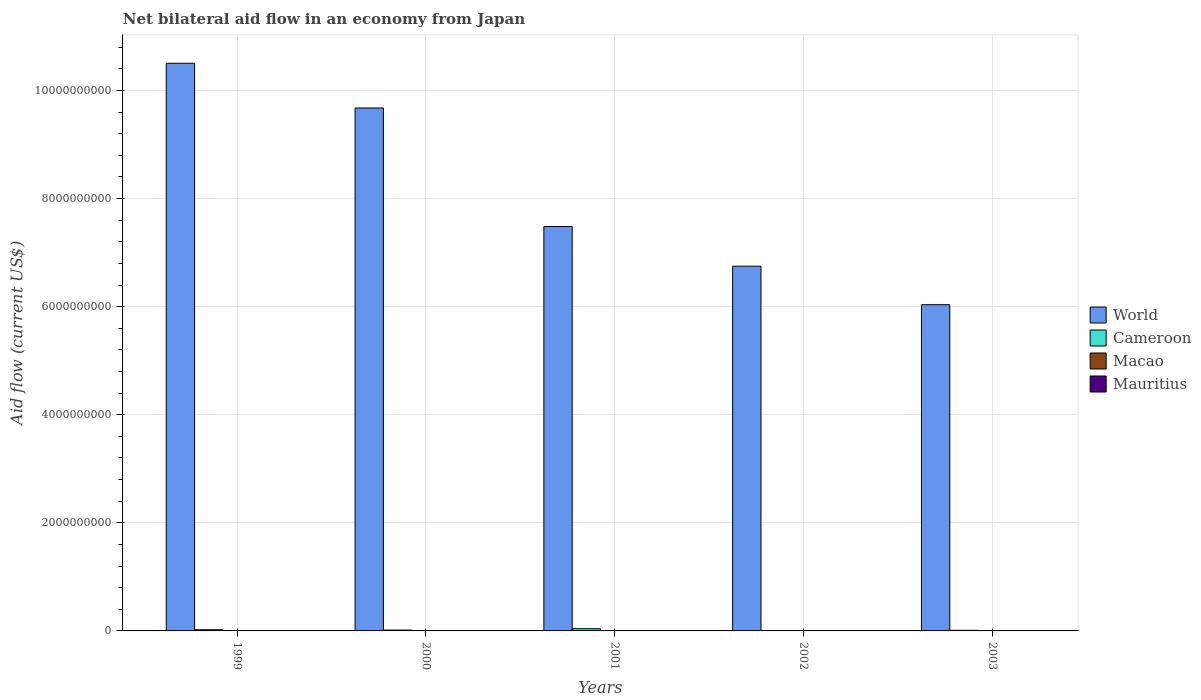How many different coloured bars are there?
Keep it short and to the point. 4. How many bars are there on the 2nd tick from the right?
Provide a succinct answer. 4. What is the net bilateral aid flow in World in 2003?
Provide a succinct answer. 6.04e+09. Across all years, what is the maximum net bilateral aid flow in Mauritius?
Offer a very short reply. 2.92e+06. Across all years, what is the minimum net bilateral aid flow in Mauritius?
Make the answer very short. 6.90e+05. In which year was the net bilateral aid flow in Mauritius maximum?
Keep it short and to the point. 2003. What is the total net bilateral aid flow in Cameroon in the graph?
Offer a terse response. 9.73e+07. What is the difference between the net bilateral aid flow in World in 2000 and that in 2003?
Offer a very short reply. 3.64e+09. What is the difference between the net bilateral aid flow in Mauritius in 2003 and the net bilateral aid flow in Cameroon in 2002?
Offer a terse response. -4.59e+06. What is the average net bilateral aid flow in Mauritius per year?
Provide a short and direct response. 1.95e+06. In the year 2000, what is the difference between the net bilateral aid flow in Macao and net bilateral aid flow in Mauritius?
Your answer should be compact. -1.98e+06. In how many years, is the net bilateral aid flow in World greater than 4000000000 US$?
Ensure brevity in your answer.  5. What is the ratio of the net bilateral aid flow in Macao in 1999 to that in 2000?
Offer a very short reply. 1.4. Is the net bilateral aid flow in Mauritius in 1999 less than that in 2003?
Offer a very short reply. Yes. Is the difference between the net bilateral aid flow in Macao in 2000 and 2002 greater than the difference between the net bilateral aid flow in Mauritius in 2000 and 2002?
Provide a short and direct response. No. What is the difference between the highest and the second highest net bilateral aid flow in World?
Make the answer very short. 8.27e+08. What is the difference between the highest and the lowest net bilateral aid flow in Mauritius?
Provide a short and direct response. 2.23e+06. Is the sum of the net bilateral aid flow in World in 1999 and 2000 greater than the maximum net bilateral aid flow in Macao across all years?
Make the answer very short. Yes. Is it the case that in every year, the sum of the net bilateral aid flow in Mauritius and net bilateral aid flow in Cameroon is greater than the sum of net bilateral aid flow in Macao and net bilateral aid flow in World?
Provide a succinct answer. Yes. What does the 4th bar from the left in 2001 represents?
Provide a short and direct response. Mauritius. How many bars are there?
Ensure brevity in your answer.  20. Are all the bars in the graph horizontal?
Ensure brevity in your answer.  No. How many years are there in the graph?
Offer a terse response. 5. Does the graph contain grids?
Your answer should be compact. Yes. What is the title of the graph?
Provide a short and direct response. Net bilateral aid flow in an economy from Japan. Does "Belgium" appear as one of the legend labels in the graph?
Ensure brevity in your answer.  No. What is the label or title of the X-axis?
Your answer should be compact. Years. What is the Aid flow (current US$) in World in 1999?
Ensure brevity in your answer.  1.05e+1. What is the Aid flow (current US$) of Cameroon in 1999?
Offer a terse response. 2.19e+07. What is the Aid flow (current US$) of Mauritius in 1999?
Offer a very short reply. 2.72e+06. What is the Aid flow (current US$) of World in 2000?
Offer a very short reply. 9.68e+09. What is the Aid flow (current US$) of Cameroon in 2000?
Your answer should be compact. 1.58e+07. What is the Aid flow (current US$) of Macao in 2000?
Keep it short and to the point. 1.50e+05. What is the Aid flow (current US$) in Mauritius in 2000?
Keep it short and to the point. 2.13e+06. What is the Aid flow (current US$) in World in 2001?
Offer a terse response. 7.48e+09. What is the Aid flow (current US$) in Cameroon in 2001?
Give a very brief answer. 4.13e+07. What is the Aid flow (current US$) of Mauritius in 2001?
Your answer should be very brief. 1.30e+06. What is the Aid flow (current US$) of World in 2002?
Provide a succinct answer. 6.75e+09. What is the Aid flow (current US$) in Cameroon in 2002?
Offer a terse response. 7.51e+06. What is the Aid flow (current US$) of Macao in 2002?
Keep it short and to the point. 1.00e+05. What is the Aid flow (current US$) of Mauritius in 2002?
Your response must be concise. 6.90e+05. What is the Aid flow (current US$) of World in 2003?
Give a very brief answer. 6.04e+09. What is the Aid flow (current US$) of Cameroon in 2003?
Your response must be concise. 1.08e+07. What is the Aid flow (current US$) in Macao in 2003?
Offer a very short reply. 8.00e+04. What is the Aid flow (current US$) in Mauritius in 2003?
Make the answer very short. 2.92e+06. Across all years, what is the maximum Aid flow (current US$) of World?
Ensure brevity in your answer.  1.05e+1. Across all years, what is the maximum Aid flow (current US$) of Cameroon?
Keep it short and to the point. 4.13e+07. Across all years, what is the maximum Aid flow (current US$) in Macao?
Keep it short and to the point. 2.10e+05. Across all years, what is the maximum Aid flow (current US$) of Mauritius?
Your answer should be very brief. 2.92e+06. Across all years, what is the minimum Aid flow (current US$) in World?
Offer a terse response. 6.04e+09. Across all years, what is the minimum Aid flow (current US$) in Cameroon?
Keep it short and to the point. 7.51e+06. Across all years, what is the minimum Aid flow (current US$) in Macao?
Provide a succinct answer. 8.00e+04. Across all years, what is the minimum Aid flow (current US$) of Mauritius?
Give a very brief answer. 6.90e+05. What is the total Aid flow (current US$) in World in the graph?
Your answer should be compact. 4.04e+1. What is the total Aid flow (current US$) of Cameroon in the graph?
Provide a succinct answer. 9.73e+07. What is the total Aid flow (current US$) in Macao in the graph?
Your answer should be very brief. 6.70e+05. What is the total Aid flow (current US$) of Mauritius in the graph?
Offer a very short reply. 9.76e+06. What is the difference between the Aid flow (current US$) of World in 1999 and that in 2000?
Ensure brevity in your answer.  8.27e+08. What is the difference between the Aid flow (current US$) of Cameroon in 1999 and that in 2000?
Provide a short and direct response. 6.09e+06. What is the difference between the Aid flow (current US$) of Macao in 1999 and that in 2000?
Offer a very short reply. 6.00e+04. What is the difference between the Aid flow (current US$) of Mauritius in 1999 and that in 2000?
Provide a short and direct response. 5.90e+05. What is the difference between the Aid flow (current US$) in World in 1999 and that in 2001?
Keep it short and to the point. 3.02e+09. What is the difference between the Aid flow (current US$) of Cameroon in 1999 and that in 2001?
Offer a very short reply. -1.94e+07. What is the difference between the Aid flow (current US$) in Mauritius in 1999 and that in 2001?
Make the answer very short. 1.42e+06. What is the difference between the Aid flow (current US$) of World in 1999 and that in 2002?
Your response must be concise. 3.75e+09. What is the difference between the Aid flow (current US$) of Cameroon in 1999 and that in 2002?
Your response must be concise. 1.44e+07. What is the difference between the Aid flow (current US$) of Macao in 1999 and that in 2002?
Keep it short and to the point. 1.10e+05. What is the difference between the Aid flow (current US$) in Mauritius in 1999 and that in 2002?
Keep it short and to the point. 2.03e+06. What is the difference between the Aid flow (current US$) of World in 1999 and that in 2003?
Ensure brevity in your answer.  4.47e+09. What is the difference between the Aid flow (current US$) of Cameroon in 1999 and that in 2003?
Keep it short and to the point. 1.11e+07. What is the difference between the Aid flow (current US$) of Macao in 1999 and that in 2003?
Provide a succinct answer. 1.30e+05. What is the difference between the Aid flow (current US$) of World in 2000 and that in 2001?
Give a very brief answer. 2.19e+09. What is the difference between the Aid flow (current US$) in Cameroon in 2000 and that in 2001?
Keep it short and to the point. -2.55e+07. What is the difference between the Aid flow (current US$) of Macao in 2000 and that in 2001?
Provide a short and direct response. 2.00e+04. What is the difference between the Aid flow (current US$) in Mauritius in 2000 and that in 2001?
Your response must be concise. 8.30e+05. What is the difference between the Aid flow (current US$) of World in 2000 and that in 2002?
Your response must be concise. 2.93e+09. What is the difference between the Aid flow (current US$) of Cameroon in 2000 and that in 2002?
Ensure brevity in your answer.  8.30e+06. What is the difference between the Aid flow (current US$) in Macao in 2000 and that in 2002?
Your response must be concise. 5.00e+04. What is the difference between the Aid flow (current US$) of Mauritius in 2000 and that in 2002?
Offer a terse response. 1.44e+06. What is the difference between the Aid flow (current US$) of World in 2000 and that in 2003?
Keep it short and to the point. 3.64e+09. What is the difference between the Aid flow (current US$) in Cameroon in 2000 and that in 2003?
Ensure brevity in your answer.  5.02e+06. What is the difference between the Aid flow (current US$) of Mauritius in 2000 and that in 2003?
Ensure brevity in your answer.  -7.90e+05. What is the difference between the Aid flow (current US$) in World in 2001 and that in 2002?
Offer a very short reply. 7.34e+08. What is the difference between the Aid flow (current US$) of Cameroon in 2001 and that in 2002?
Provide a succinct answer. 3.38e+07. What is the difference between the Aid flow (current US$) of Macao in 2001 and that in 2002?
Offer a very short reply. 3.00e+04. What is the difference between the Aid flow (current US$) in Mauritius in 2001 and that in 2002?
Keep it short and to the point. 6.10e+05. What is the difference between the Aid flow (current US$) of World in 2001 and that in 2003?
Your response must be concise. 1.45e+09. What is the difference between the Aid flow (current US$) in Cameroon in 2001 and that in 2003?
Provide a succinct answer. 3.05e+07. What is the difference between the Aid flow (current US$) of Macao in 2001 and that in 2003?
Offer a terse response. 5.00e+04. What is the difference between the Aid flow (current US$) in Mauritius in 2001 and that in 2003?
Your answer should be compact. -1.62e+06. What is the difference between the Aid flow (current US$) in World in 2002 and that in 2003?
Keep it short and to the point. 7.12e+08. What is the difference between the Aid flow (current US$) in Cameroon in 2002 and that in 2003?
Offer a terse response. -3.28e+06. What is the difference between the Aid flow (current US$) of Macao in 2002 and that in 2003?
Keep it short and to the point. 2.00e+04. What is the difference between the Aid flow (current US$) of Mauritius in 2002 and that in 2003?
Your answer should be compact. -2.23e+06. What is the difference between the Aid flow (current US$) of World in 1999 and the Aid flow (current US$) of Cameroon in 2000?
Offer a terse response. 1.05e+1. What is the difference between the Aid flow (current US$) in World in 1999 and the Aid flow (current US$) in Macao in 2000?
Give a very brief answer. 1.05e+1. What is the difference between the Aid flow (current US$) of World in 1999 and the Aid flow (current US$) of Mauritius in 2000?
Offer a very short reply. 1.05e+1. What is the difference between the Aid flow (current US$) in Cameroon in 1999 and the Aid flow (current US$) in Macao in 2000?
Offer a very short reply. 2.18e+07. What is the difference between the Aid flow (current US$) of Cameroon in 1999 and the Aid flow (current US$) of Mauritius in 2000?
Keep it short and to the point. 1.98e+07. What is the difference between the Aid flow (current US$) of Macao in 1999 and the Aid flow (current US$) of Mauritius in 2000?
Your response must be concise. -1.92e+06. What is the difference between the Aid flow (current US$) of World in 1999 and the Aid flow (current US$) of Cameroon in 2001?
Make the answer very short. 1.05e+1. What is the difference between the Aid flow (current US$) of World in 1999 and the Aid flow (current US$) of Macao in 2001?
Your answer should be compact. 1.05e+1. What is the difference between the Aid flow (current US$) of World in 1999 and the Aid flow (current US$) of Mauritius in 2001?
Provide a short and direct response. 1.05e+1. What is the difference between the Aid flow (current US$) in Cameroon in 1999 and the Aid flow (current US$) in Macao in 2001?
Your answer should be very brief. 2.18e+07. What is the difference between the Aid flow (current US$) in Cameroon in 1999 and the Aid flow (current US$) in Mauritius in 2001?
Your response must be concise. 2.06e+07. What is the difference between the Aid flow (current US$) in Macao in 1999 and the Aid flow (current US$) in Mauritius in 2001?
Provide a succinct answer. -1.09e+06. What is the difference between the Aid flow (current US$) of World in 1999 and the Aid flow (current US$) of Cameroon in 2002?
Your response must be concise. 1.05e+1. What is the difference between the Aid flow (current US$) in World in 1999 and the Aid flow (current US$) in Macao in 2002?
Your answer should be very brief. 1.05e+1. What is the difference between the Aid flow (current US$) of World in 1999 and the Aid flow (current US$) of Mauritius in 2002?
Provide a short and direct response. 1.05e+1. What is the difference between the Aid flow (current US$) in Cameroon in 1999 and the Aid flow (current US$) in Macao in 2002?
Offer a very short reply. 2.18e+07. What is the difference between the Aid flow (current US$) in Cameroon in 1999 and the Aid flow (current US$) in Mauritius in 2002?
Offer a very short reply. 2.12e+07. What is the difference between the Aid flow (current US$) of Macao in 1999 and the Aid flow (current US$) of Mauritius in 2002?
Offer a terse response. -4.80e+05. What is the difference between the Aid flow (current US$) of World in 1999 and the Aid flow (current US$) of Cameroon in 2003?
Make the answer very short. 1.05e+1. What is the difference between the Aid flow (current US$) of World in 1999 and the Aid flow (current US$) of Macao in 2003?
Provide a short and direct response. 1.05e+1. What is the difference between the Aid flow (current US$) of World in 1999 and the Aid flow (current US$) of Mauritius in 2003?
Your answer should be very brief. 1.05e+1. What is the difference between the Aid flow (current US$) of Cameroon in 1999 and the Aid flow (current US$) of Macao in 2003?
Your answer should be compact. 2.18e+07. What is the difference between the Aid flow (current US$) of Cameroon in 1999 and the Aid flow (current US$) of Mauritius in 2003?
Provide a short and direct response. 1.90e+07. What is the difference between the Aid flow (current US$) of Macao in 1999 and the Aid flow (current US$) of Mauritius in 2003?
Provide a succinct answer. -2.71e+06. What is the difference between the Aid flow (current US$) of World in 2000 and the Aid flow (current US$) of Cameroon in 2001?
Offer a terse response. 9.63e+09. What is the difference between the Aid flow (current US$) in World in 2000 and the Aid flow (current US$) in Macao in 2001?
Offer a terse response. 9.68e+09. What is the difference between the Aid flow (current US$) of World in 2000 and the Aid flow (current US$) of Mauritius in 2001?
Offer a very short reply. 9.67e+09. What is the difference between the Aid flow (current US$) of Cameroon in 2000 and the Aid flow (current US$) of Macao in 2001?
Provide a succinct answer. 1.57e+07. What is the difference between the Aid flow (current US$) of Cameroon in 2000 and the Aid flow (current US$) of Mauritius in 2001?
Provide a short and direct response. 1.45e+07. What is the difference between the Aid flow (current US$) of Macao in 2000 and the Aid flow (current US$) of Mauritius in 2001?
Offer a very short reply. -1.15e+06. What is the difference between the Aid flow (current US$) in World in 2000 and the Aid flow (current US$) in Cameroon in 2002?
Your response must be concise. 9.67e+09. What is the difference between the Aid flow (current US$) in World in 2000 and the Aid flow (current US$) in Macao in 2002?
Provide a succinct answer. 9.68e+09. What is the difference between the Aid flow (current US$) of World in 2000 and the Aid flow (current US$) of Mauritius in 2002?
Offer a very short reply. 9.67e+09. What is the difference between the Aid flow (current US$) of Cameroon in 2000 and the Aid flow (current US$) of Macao in 2002?
Your answer should be very brief. 1.57e+07. What is the difference between the Aid flow (current US$) of Cameroon in 2000 and the Aid flow (current US$) of Mauritius in 2002?
Your answer should be very brief. 1.51e+07. What is the difference between the Aid flow (current US$) in Macao in 2000 and the Aid flow (current US$) in Mauritius in 2002?
Offer a very short reply. -5.40e+05. What is the difference between the Aid flow (current US$) of World in 2000 and the Aid flow (current US$) of Cameroon in 2003?
Make the answer very short. 9.66e+09. What is the difference between the Aid flow (current US$) of World in 2000 and the Aid flow (current US$) of Macao in 2003?
Offer a terse response. 9.68e+09. What is the difference between the Aid flow (current US$) in World in 2000 and the Aid flow (current US$) in Mauritius in 2003?
Give a very brief answer. 9.67e+09. What is the difference between the Aid flow (current US$) of Cameroon in 2000 and the Aid flow (current US$) of Macao in 2003?
Give a very brief answer. 1.57e+07. What is the difference between the Aid flow (current US$) in Cameroon in 2000 and the Aid flow (current US$) in Mauritius in 2003?
Your answer should be very brief. 1.29e+07. What is the difference between the Aid flow (current US$) of Macao in 2000 and the Aid flow (current US$) of Mauritius in 2003?
Your answer should be compact. -2.77e+06. What is the difference between the Aid flow (current US$) of World in 2001 and the Aid flow (current US$) of Cameroon in 2002?
Your response must be concise. 7.47e+09. What is the difference between the Aid flow (current US$) of World in 2001 and the Aid flow (current US$) of Macao in 2002?
Your response must be concise. 7.48e+09. What is the difference between the Aid flow (current US$) in World in 2001 and the Aid flow (current US$) in Mauritius in 2002?
Offer a very short reply. 7.48e+09. What is the difference between the Aid flow (current US$) of Cameroon in 2001 and the Aid flow (current US$) of Macao in 2002?
Your answer should be very brief. 4.12e+07. What is the difference between the Aid flow (current US$) of Cameroon in 2001 and the Aid flow (current US$) of Mauritius in 2002?
Give a very brief answer. 4.06e+07. What is the difference between the Aid flow (current US$) in Macao in 2001 and the Aid flow (current US$) in Mauritius in 2002?
Make the answer very short. -5.60e+05. What is the difference between the Aid flow (current US$) in World in 2001 and the Aid flow (current US$) in Cameroon in 2003?
Make the answer very short. 7.47e+09. What is the difference between the Aid flow (current US$) in World in 2001 and the Aid flow (current US$) in Macao in 2003?
Offer a terse response. 7.48e+09. What is the difference between the Aid flow (current US$) in World in 2001 and the Aid flow (current US$) in Mauritius in 2003?
Your answer should be compact. 7.48e+09. What is the difference between the Aid flow (current US$) in Cameroon in 2001 and the Aid flow (current US$) in Macao in 2003?
Offer a very short reply. 4.12e+07. What is the difference between the Aid flow (current US$) of Cameroon in 2001 and the Aid flow (current US$) of Mauritius in 2003?
Provide a succinct answer. 3.84e+07. What is the difference between the Aid flow (current US$) in Macao in 2001 and the Aid flow (current US$) in Mauritius in 2003?
Your answer should be very brief. -2.79e+06. What is the difference between the Aid flow (current US$) of World in 2002 and the Aid flow (current US$) of Cameroon in 2003?
Your answer should be very brief. 6.74e+09. What is the difference between the Aid flow (current US$) in World in 2002 and the Aid flow (current US$) in Macao in 2003?
Your answer should be very brief. 6.75e+09. What is the difference between the Aid flow (current US$) of World in 2002 and the Aid flow (current US$) of Mauritius in 2003?
Keep it short and to the point. 6.75e+09. What is the difference between the Aid flow (current US$) of Cameroon in 2002 and the Aid flow (current US$) of Macao in 2003?
Provide a short and direct response. 7.43e+06. What is the difference between the Aid flow (current US$) of Cameroon in 2002 and the Aid flow (current US$) of Mauritius in 2003?
Your answer should be compact. 4.59e+06. What is the difference between the Aid flow (current US$) in Macao in 2002 and the Aid flow (current US$) in Mauritius in 2003?
Your answer should be very brief. -2.82e+06. What is the average Aid flow (current US$) of World per year?
Provide a short and direct response. 8.09e+09. What is the average Aid flow (current US$) in Cameroon per year?
Give a very brief answer. 1.95e+07. What is the average Aid flow (current US$) of Macao per year?
Provide a short and direct response. 1.34e+05. What is the average Aid flow (current US$) in Mauritius per year?
Ensure brevity in your answer.  1.95e+06. In the year 1999, what is the difference between the Aid flow (current US$) in World and Aid flow (current US$) in Cameroon?
Your response must be concise. 1.05e+1. In the year 1999, what is the difference between the Aid flow (current US$) of World and Aid flow (current US$) of Macao?
Your response must be concise. 1.05e+1. In the year 1999, what is the difference between the Aid flow (current US$) in World and Aid flow (current US$) in Mauritius?
Provide a succinct answer. 1.05e+1. In the year 1999, what is the difference between the Aid flow (current US$) of Cameroon and Aid flow (current US$) of Macao?
Keep it short and to the point. 2.17e+07. In the year 1999, what is the difference between the Aid flow (current US$) in Cameroon and Aid flow (current US$) in Mauritius?
Keep it short and to the point. 1.92e+07. In the year 1999, what is the difference between the Aid flow (current US$) of Macao and Aid flow (current US$) of Mauritius?
Your answer should be very brief. -2.51e+06. In the year 2000, what is the difference between the Aid flow (current US$) of World and Aid flow (current US$) of Cameroon?
Ensure brevity in your answer.  9.66e+09. In the year 2000, what is the difference between the Aid flow (current US$) in World and Aid flow (current US$) in Macao?
Your answer should be compact. 9.68e+09. In the year 2000, what is the difference between the Aid flow (current US$) of World and Aid flow (current US$) of Mauritius?
Your response must be concise. 9.67e+09. In the year 2000, what is the difference between the Aid flow (current US$) of Cameroon and Aid flow (current US$) of Macao?
Give a very brief answer. 1.57e+07. In the year 2000, what is the difference between the Aid flow (current US$) of Cameroon and Aid flow (current US$) of Mauritius?
Offer a very short reply. 1.37e+07. In the year 2000, what is the difference between the Aid flow (current US$) of Macao and Aid flow (current US$) of Mauritius?
Ensure brevity in your answer.  -1.98e+06. In the year 2001, what is the difference between the Aid flow (current US$) in World and Aid flow (current US$) in Cameroon?
Give a very brief answer. 7.44e+09. In the year 2001, what is the difference between the Aid flow (current US$) of World and Aid flow (current US$) of Macao?
Offer a terse response. 7.48e+09. In the year 2001, what is the difference between the Aid flow (current US$) of World and Aid flow (current US$) of Mauritius?
Keep it short and to the point. 7.48e+09. In the year 2001, what is the difference between the Aid flow (current US$) of Cameroon and Aid flow (current US$) of Macao?
Your response must be concise. 4.12e+07. In the year 2001, what is the difference between the Aid flow (current US$) in Cameroon and Aid flow (current US$) in Mauritius?
Your answer should be very brief. 4.00e+07. In the year 2001, what is the difference between the Aid flow (current US$) of Macao and Aid flow (current US$) of Mauritius?
Ensure brevity in your answer.  -1.17e+06. In the year 2002, what is the difference between the Aid flow (current US$) of World and Aid flow (current US$) of Cameroon?
Give a very brief answer. 6.74e+09. In the year 2002, what is the difference between the Aid flow (current US$) in World and Aid flow (current US$) in Macao?
Give a very brief answer. 6.75e+09. In the year 2002, what is the difference between the Aid flow (current US$) in World and Aid flow (current US$) in Mauritius?
Offer a very short reply. 6.75e+09. In the year 2002, what is the difference between the Aid flow (current US$) of Cameroon and Aid flow (current US$) of Macao?
Give a very brief answer. 7.41e+06. In the year 2002, what is the difference between the Aid flow (current US$) of Cameroon and Aid flow (current US$) of Mauritius?
Provide a succinct answer. 6.82e+06. In the year 2002, what is the difference between the Aid flow (current US$) of Macao and Aid flow (current US$) of Mauritius?
Give a very brief answer. -5.90e+05. In the year 2003, what is the difference between the Aid flow (current US$) in World and Aid flow (current US$) in Cameroon?
Your answer should be compact. 6.03e+09. In the year 2003, what is the difference between the Aid flow (current US$) of World and Aid flow (current US$) of Macao?
Offer a very short reply. 6.04e+09. In the year 2003, what is the difference between the Aid flow (current US$) of World and Aid flow (current US$) of Mauritius?
Make the answer very short. 6.03e+09. In the year 2003, what is the difference between the Aid flow (current US$) of Cameroon and Aid flow (current US$) of Macao?
Offer a very short reply. 1.07e+07. In the year 2003, what is the difference between the Aid flow (current US$) of Cameroon and Aid flow (current US$) of Mauritius?
Make the answer very short. 7.87e+06. In the year 2003, what is the difference between the Aid flow (current US$) of Macao and Aid flow (current US$) of Mauritius?
Your answer should be very brief. -2.84e+06. What is the ratio of the Aid flow (current US$) of World in 1999 to that in 2000?
Offer a terse response. 1.09. What is the ratio of the Aid flow (current US$) of Cameroon in 1999 to that in 2000?
Provide a short and direct response. 1.39. What is the ratio of the Aid flow (current US$) of Macao in 1999 to that in 2000?
Your answer should be very brief. 1.4. What is the ratio of the Aid flow (current US$) of Mauritius in 1999 to that in 2000?
Make the answer very short. 1.28. What is the ratio of the Aid flow (current US$) in World in 1999 to that in 2001?
Make the answer very short. 1.4. What is the ratio of the Aid flow (current US$) of Cameroon in 1999 to that in 2001?
Your answer should be compact. 0.53. What is the ratio of the Aid flow (current US$) in Macao in 1999 to that in 2001?
Provide a short and direct response. 1.62. What is the ratio of the Aid flow (current US$) of Mauritius in 1999 to that in 2001?
Give a very brief answer. 2.09. What is the ratio of the Aid flow (current US$) of World in 1999 to that in 2002?
Make the answer very short. 1.56. What is the ratio of the Aid flow (current US$) in Cameroon in 1999 to that in 2002?
Offer a terse response. 2.92. What is the ratio of the Aid flow (current US$) of Macao in 1999 to that in 2002?
Give a very brief answer. 2.1. What is the ratio of the Aid flow (current US$) in Mauritius in 1999 to that in 2002?
Give a very brief answer. 3.94. What is the ratio of the Aid flow (current US$) of World in 1999 to that in 2003?
Offer a very short reply. 1.74. What is the ratio of the Aid flow (current US$) of Cameroon in 1999 to that in 2003?
Offer a very short reply. 2.03. What is the ratio of the Aid flow (current US$) in Macao in 1999 to that in 2003?
Offer a very short reply. 2.62. What is the ratio of the Aid flow (current US$) in Mauritius in 1999 to that in 2003?
Offer a very short reply. 0.93. What is the ratio of the Aid flow (current US$) of World in 2000 to that in 2001?
Your answer should be compact. 1.29. What is the ratio of the Aid flow (current US$) in Cameroon in 2000 to that in 2001?
Offer a very short reply. 0.38. What is the ratio of the Aid flow (current US$) in Macao in 2000 to that in 2001?
Your answer should be compact. 1.15. What is the ratio of the Aid flow (current US$) in Mauritius in 2000 to that in 2001?
Keep it short and to the point. 1.64. What is the ratio of the Aid flow (current US$) in World in 2000 to that in 2002?
Your answer should be very brief. 1.43. What is the ratio of the Aid flow (current US$) of Cameroon in 2000 to that in 2002?
Offer a terse response. 2.11. What is the ratio of the Aid flow (current US$) in Mauritius in 2000 to that in 2002?
Make the answer very short. 3.09. What is the ratio of the Aid flow (current US$) of World in 2000 to that in 2003?
Ensure brevity in your answer.  1.6. What is the ratio of the Aid flow (current US$) in Cameroon in 2000 to that in 2003?
Your response must be concise. 1.47. What is the ratio of the Aid flow (current US$) of Macao in 2000 to that in 2003?
Your answer should be very brief. 1.88. What is the ratio of the Aid flow (current US$) of Mauritius in 2000 to that in 2003?
Keep it short and to the point. 0.73. What is the ratio of the Aid flow (current US$) in World in 2001 to that in 2002?
Make the answer very short. 1.11. What is the ratio of the Aid flow (current US$) in Cameroon in 2001 to that in 2002?
Make the answer very short. 5.5. What is the ratio of the Aid flow (current US$) in Mauritius in 2001 to that in 2002?
Make the answer very short. 1.88. What is the ratio of the Aid flow (current US$) in World in 2001 to that in 2003?
Offer a terse response. 1.24. What is the ratio of the Aid flow (current US$) in Cameroon in 2001 to that in 2003?
Provide a short and direct response. 3.83. What is the ratio of the Aid flow (current US$) in Macao in 2001 to that in 2003?
Give a very brief answer. 1.62. What is the ratio of the Aid flow (current US$) of Mauritius in 2001 to that in 2003?
Your response must be concise. 0.45. What is the ratio of the Aid flow (current US$) in World in 2002 to that in 2003?
Offer a terse response. 1.12. What is the ratio of the Aid flow (current US$) in Cameroon in 2002 to that in 2003?
Your answer should be compact. 0.7. What is the ratio of the Aid flow (current US$) in Macao in 2002 to that in 2003?
Provide a short and direct response. 1.25. What is the ratio of the Aid flow (current US$) of Mauritius in 2002 to that in 2003?
Give a very brief answer. 0.24. What is the difference between the highest and the second highest Aid flow (current US$) in World?
Your response must be concise. 8.27e+08. What is the difference between the highest and the second highest Aid flow (current US$) in Cameroon?
Ensure brevity in your answer.  1.94e+07. What is the difference between the highest and the second highest Aid flow (current US$) in Mauritius?
Your answer should be very brief. 2.00e+05. What is the difference between the highest and the lowest Aid flow (current US$) of World?
Give a very brief answer. 4.47e+09. What is the difference between the highest and the lowest Aid flow (current US$) in Cameroon?
Your answer should be compact. 3.38e+07. What is the difference between the highest and the lowest Aid flow (current US$) in Macao?
Make the answer very short. 1.30e+05. What is the difference between the highest and the lowest Aid flow (current US$) in Mauritius?
Provide a succinct answer. 2.23e+06. 